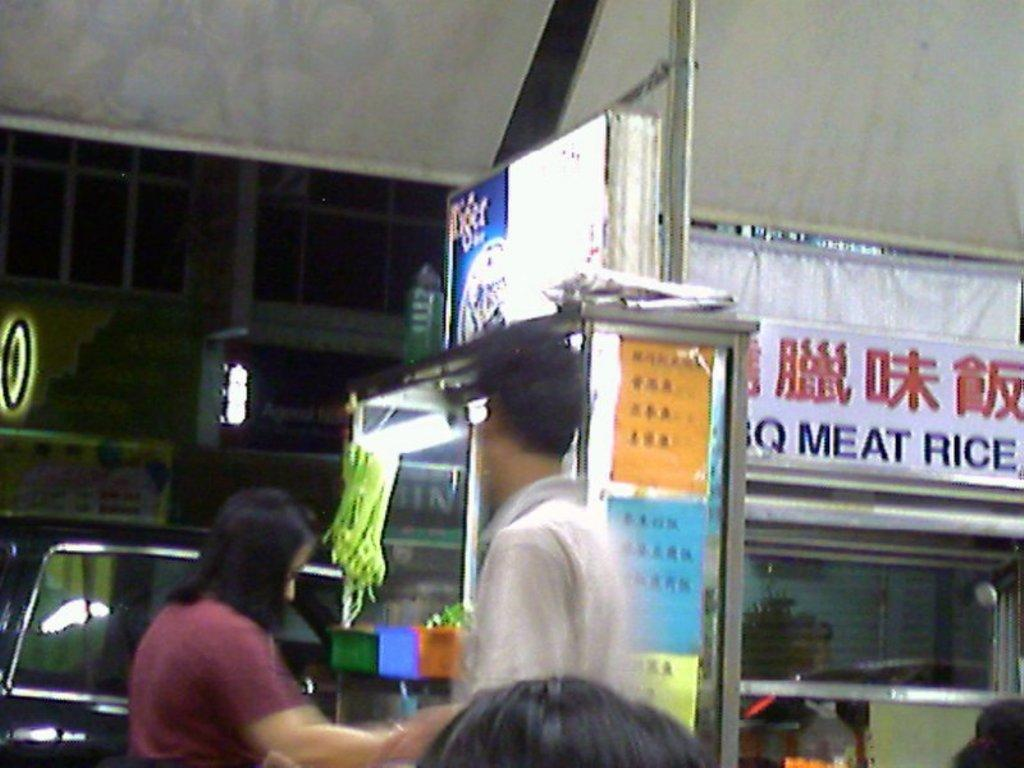Who or what can be seen in the image? There are people in the image. What type of structures are visible in the image? There are buildings with name boards in the image. Is there any mode of transportation present in the image? Yes, there is a vehicle in the image. What can be seen illuminating the scene in the image? There are lights in the image. What type of spoon is being used to fix the error in the image? There is no spoon or error present in the image. 